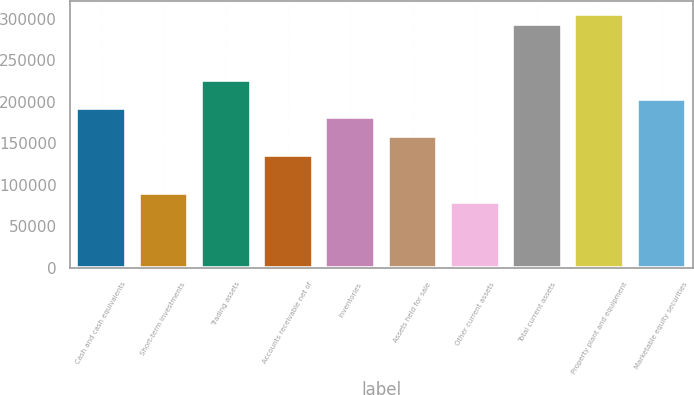<chart> <loc_0><loc_0><loc_500><loc_500><bar_chart><fcel>Cash and cash equivalents<fcel>Short-term investments<fcel>Trading assets<fcel>Accounts receivable net of<fcel>Inventories<fcel>Assets held for sale<fcel>Other current assets<fcel>Total current assets<fcel>Property plant and equipment<fcel>Marketable equity securities<nl><fcel>192582<fcel>90682.8<fcel>226548<fcel>135971<fcel>181260<fcel>158615<fcel>79360.7<fcel>294481<fcel>305803<fcel>203904<nl></chart> 